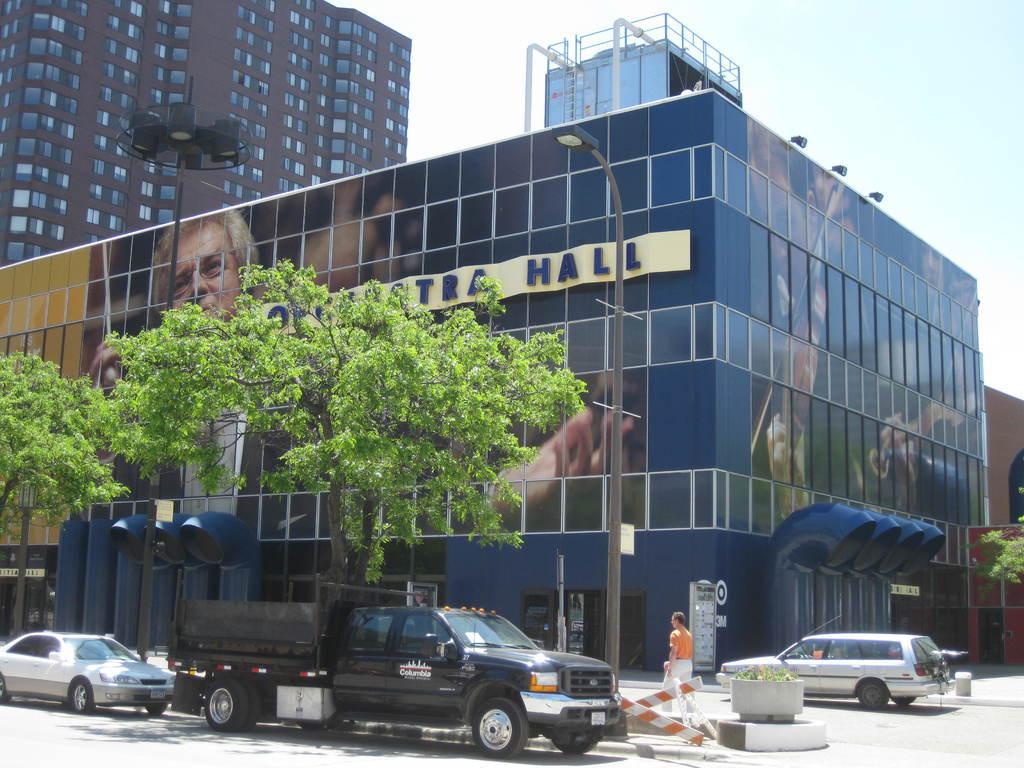Could you give a brief overview of what you see in this image? In this image in the center there is one building and in the foreground there are some vehicles and one person is walking and also there are some trees, poles, street light. At the bottom there is road, in the background there are some buildings and some lights. 